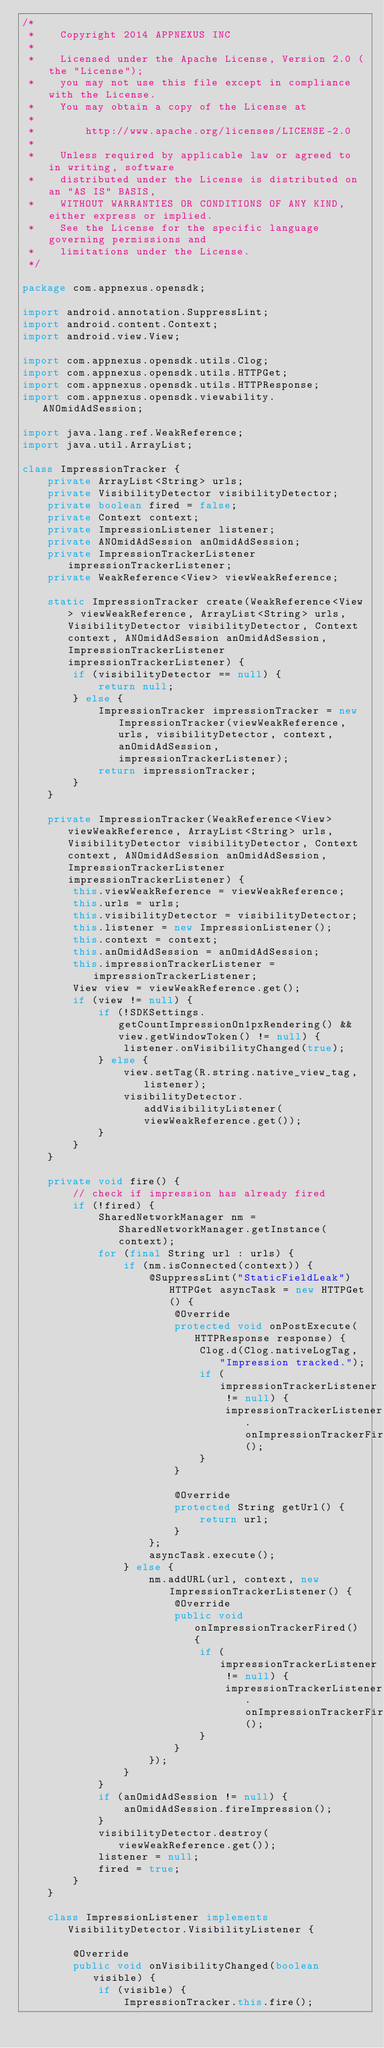<code> <loc_0><loc_0><loc_500><loc_500><_Java_>/*
 *    Copyright 2014 APPNEXUS INC
 *
 *    Licensed under the Apache License, Version 2.0 (the "License");
 *    you may not use this file except in compliance with the License.
 *    You may obtain a copy of the License at
 *
 *        http://www.apache.org/licenses/LICENSE-2.0
 *
 *    Unless required by applicable law or agreed to in writing, software
 *    distributed under the License is distributed on an "AS IS" BASIS,
 *    WITHOUT WARRANTIES OR CONDITIONS OF ANY KIND, either express or implied.
 *    See the License for the specific language governing permissions and
 *    limitations under the License.
 */

package com.appnexus.opensdk;

import android.annotation.SuppressLint;
import android.content.Context;
import android.view.View;

import com.appnexus.opensdk.utils.Clog;
import com.appnexus.opensdk.utils.HTTPGet;
import com.appnexus.opensdk.utils.HTTPResponse;
import com.appnexus.opensdk.viewability.ANOmidAdSession;

import java.lang.ref.WeakReference;
import java.util.ArrayList;

class ImpressionTracker {
    private ArrayList<String> urls;
    private VisibilityDetector visibilityDetector;
    private boolean fired = false;
    private Context context;
    private ImpressionListener listener;
    private ANOmidAdSession anOmidAdSession;
    private ImpressionTrackerListener impressionTrackerListener;
    private WeakReference<View> viewWeakReference;

    static ImpressionTracker create(WeakReference<View> viewWeakReference, ArrayList<String> urls, VisibilityDetector visibilityDetector, Context context, ANOmidAdSession anOmidAdSession, ImpressionTrackerListener impressionTrackerListener) {
        if (visibilityDetector == null) {
            return null;
        } else {
            ImpressionTracker impressionTracker = new ImpressionTracker(viewWeakReference, urls, visibilityDetector, context, anOmidAdSession, impressionTrackerListener);
            return impressionTracker;
        }
    }

    private ImpressionTracker(WeakReference<View> viewWeakReference, ArrayList<String> urls, VisibilityDetector visibilityDetector, Context context, ANOmidAdSession anOmidAdSession, ImpressionTrackerListener impressionTrackerListener) {
        this.viewWeakReference = viewWeakReference;
        this.urls = urls;
        this.visibilityDetector = visibilityDetector;
        this.listener = new ImpressionListener();
        this.context = context;
        this.anOmidAdSession = anOmidAdSession;
        this.impressionTrackerListener = impressionTrackerListener;
        View view = viewWeakReference.get();
        if (view != null) {
            if (!SDKSettings.getCountImpressionOn1pxRendering() && view.getWindowToken() != null) {
                listener.onVisibilityChanged(true);
            } else {
                view.setTag(R.string.native_view_tag, listener);
                visibilityDetector.addVisibilityListener(viewWeakReference.get());
            }
        }
    }

    private void fire() {
        // check if impression has already fired
        if (!fired) {
            SharedNetworkManager nm = SharedNetworkManager.getInstance(context);
            for (final String url : urls) {
                if (nm.isConnected(context)) {
                    @SuppressLint("StaticFieldLeak") HTTPGet asyncTask = new HTTPGet() {
                        @Override
                        protected void onPostExecute(HTTPResponse response) {
                            Clog.d(Clog.nativeLogTag, "Impression tracked.");
                            if (impressionTrackerListener != null) {
                                impressionTrackerListener.onImpressionTrackerFired();
                            }
                        }

                        @Override
                        protected String getUrl() {
                            return url;
                        }
                    };
                    asyncTask.execute();
                } else {
                    nm.addURL(url, context, new ImpressionTrackerListener() {
                        @Override
                        public void onImpressionTrackerFired() {
                            if (impressionTrackerListener != null) {
                                impressionTrackerListener.onImpressionTrackerFired();
                            }
                        }
                    });
                }
            }
            if (anOmidAdSession != null) {
                anOmidAdSession.fireImpression();
            }
            visibilityDetector.destroy(viewWeakReference.get());
            listener = null;
            fired = true;
        }
    }

    class ImpressionListener implements VisibilityDetector.VisibilityListener {

        @Override
        public void onVisibilityChanged(boolean visible) {
            if (visible) {
                ImpressionTracker.this.fire();</code> 